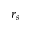<formula> <loc_0><loc_0><loc_500><loc_500>r _ { s }</formula> 